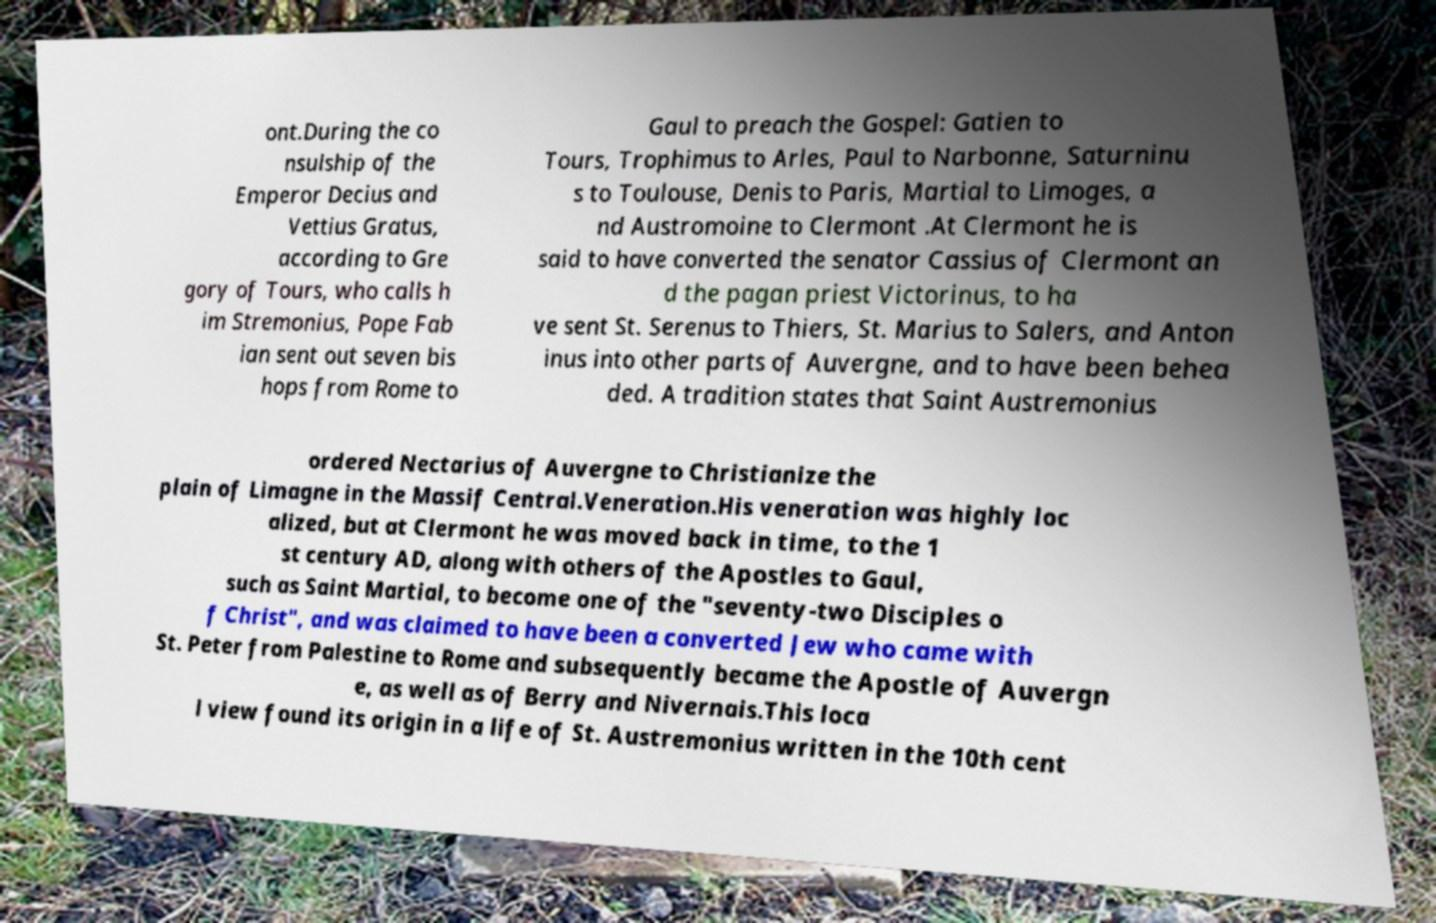What messages or text are displayed in this image? I need them in a readable, typed format. ont.During the co nsulship of the Emperor Decius and Vettius Gratus, according to Gre gory of Tours, who calls h im Stremonius, Pope Fab ian sent out seven bis hops from Rome to Gaul to preach the Gospel: Gatien to Tours, Trophimus to Arles, Paul to Narbonne, Saturninu s to Toulouse, Denis to Paris, Martial to Limoges, a nd Austromoine to Clermont .At Clermont he is said to have converted the senator Cassius of Clermont an d the pagan priest Victorinus, to ha ve sent St. Serenus to Thiers, St. Marius to Salers, and Anton inus into other parts of Auvergne, and to have been behea ded. A tradition states that Saint Austremonius ordered Nectarius of Auvergne to Christianize the plain of Limagne in the Massif Central.Veneration.His veneration was highly loc alized, but at Clermont he was moved back in time, to the 1 st century AD, along with others of the Apostles to Gaul, such as Saint Martial, to become one of the "seventy-two Disciples o f Christ", and was claimed to have been a converted Jew who came with St. Peter from Palestine to Rome and subsequently became the Apostle of Auvergn e, as well as of Berry and Nivernais.This loca l view found its origin in a life of St. Austremonius written in the 10th cent 